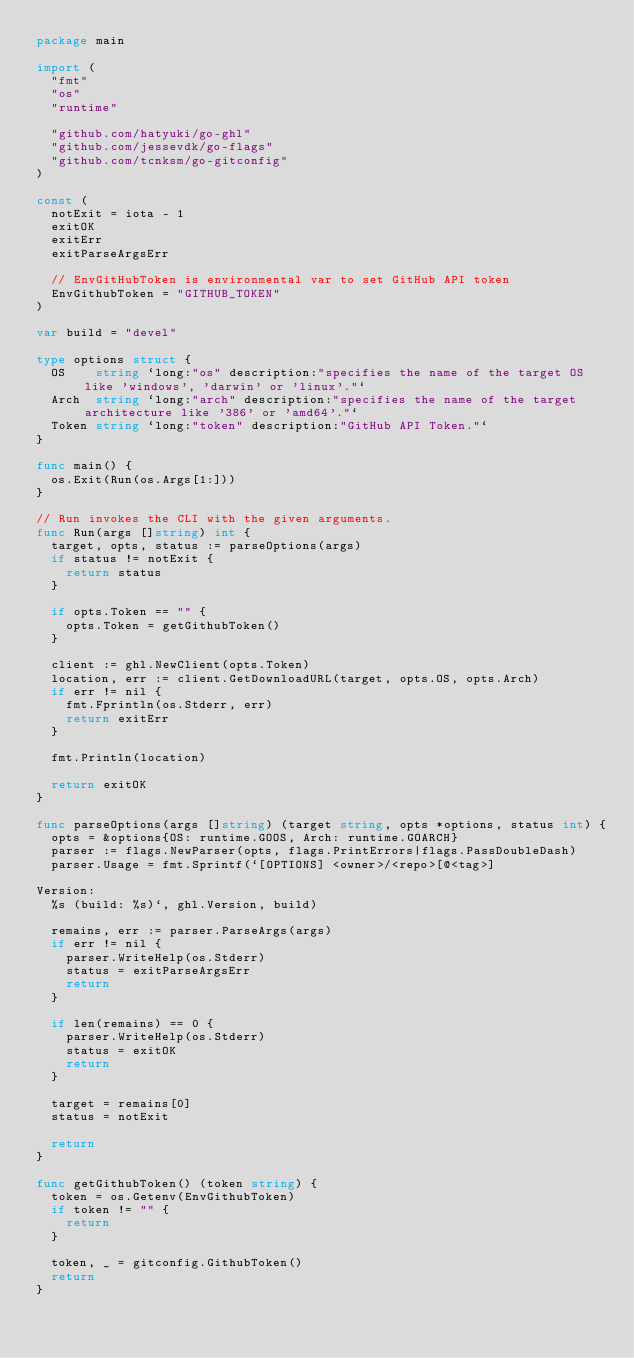Convert code to text. <code><loc_0><loc_0><loc_500><loc_500><_Go_>package main

import (
	"fmt"
	"os"
	"runtime"

	"github.com/hatyuki/go-ghl"
	"github.com/jessevdk/go-flags"
	"github.com/tcnksm/go-gitconfig"
)

const (
	notExit = iota - 1
	exitOK
	exitErr
	exitParseArgsErr

	// EnvGitHubToken is environmental var to set GitHub API token
	EnvGithubToken = "GITHUB_TOKEN"
)

var build = "devel"

type options struct {
	OS    string `long:"os" description:"specifies the name of the target OS like 'windows', 'darwin' or 'linux'."`
	Arch  string `long:"arch" description:"specifies the name of the target architecture like '386' or 'amd64'."`
	Token string `long:"token" description:"GitHub API Token."`
}

func main() {
	os.Exit(Run(os.Args[1:]))
}

// Run invokes the CLI with the given arguments.
func Run(args []string) int {
	target, opts, status := parseOptions(args)
	if status != notExit {
		return status
	}

	if opts.Token == "" {
		opts.Token = getGithubToken()
	}

	client := ghl.NewClient(opts.Token)
	location, err := client.GetDownloadURL(target, opts.OS, opts.Arch)
	if err != nil {
		fmt.Fprintln(os.Stderr, err)
		return exitErr
	}

	fmt.Println(location)

	return exitOK
}

func parseOptions(args []string) (target string, opts *options, status int) {
	opts = &options{OS: runtime.GOOS, Arch: runtime.GOARCH}
	parser := flags.NewParser(opts, flags.PrintErrors|flags.PassDoubleDash)
	parser.Usage = fmt.Sprintf(`[OPTIONS] <owner>/<repo>[@<tag>]

Version:
  %s (build: %s)`, ghl.Version, build)

	remains, err := parser.ParseArgs(args)
	if err != nil {
		parser.WriteHelp(os.Stderr)
		status = exitParseArgsErr
		return
	}

	if len(remains) == 0 {
		parser.WriteHelp(os.Stderr)
		status = exitOK
		return
	}

	target = remains[0]
	status = notExit

	return
}

func getGithubToken() (token string) {
	token = os.Getenv(EnvGithubToken)
	if token != "" {
		return
	}

	token, _ = gitconfig.GithubToken()
	return
}
</code> 